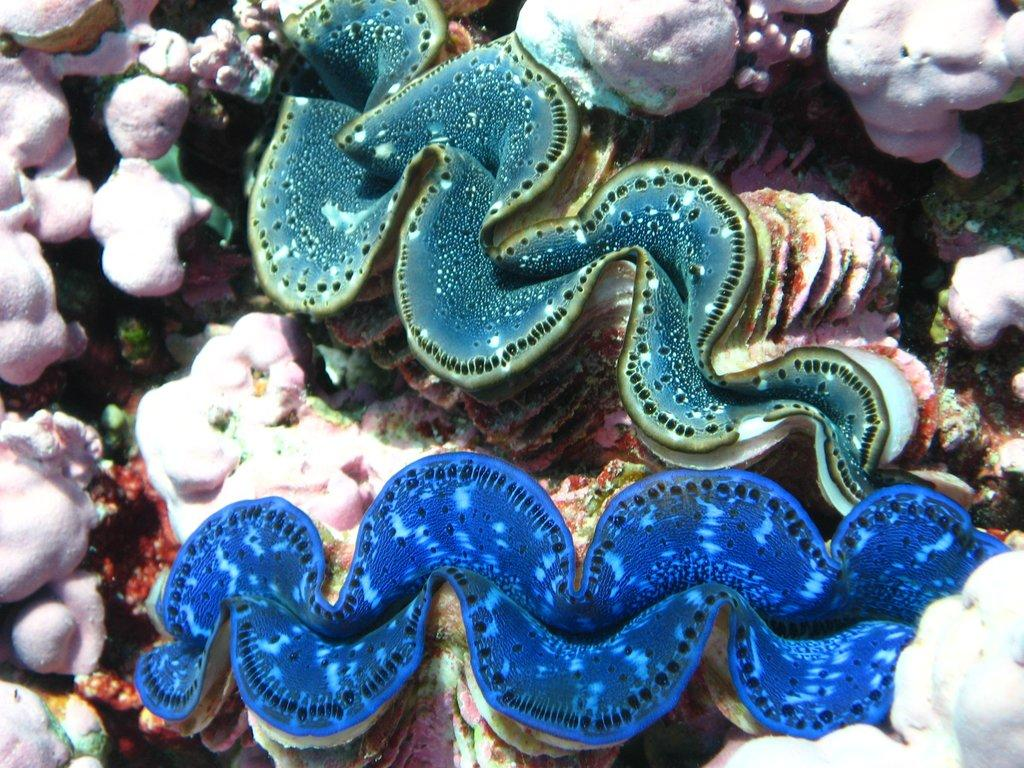What type of animals can be seen in the image? There are marine species in the image. What color are some of the objects in the image? There are pink color objects in the image. What type of wheel can be seen in the image? There is no wheel present in the image; it features marine species and pink objects. What silver object is visible in the image? There is no silver object present in the image. 